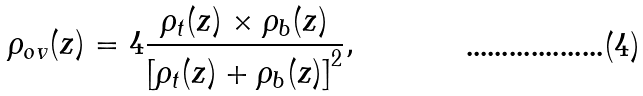Convert formula to latex. <formula><loc_0><loc_0><loc_500><loc_500>\rho _ { o v } ( z ) = 4 \frac { \rho _ { t } ( z ) \times \rho _ { b } ( z ) } { \left [ \rho _ { t } ( z ) + \rho _ { b } ( z ) \right ] ^ { 2 } } ,</formula> 